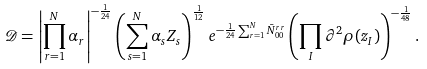Convert formula to latex. <formula><loc_0><loc_0><loc_500><loc_500>\mathcal { D } = \left | \prod _ { r = 1 } ^ { N } \alpha _ { r } \right | ^ { - \frac { 1 } { 2 4 } } \left ( \sum _ { s = 1 } ^ { N } \alpha _ { s } Z _ { s } \right ) ^ { \frac { 1 } { 1 2 } } e ^ { - \frac { 1 } { 2 4 } \sum _ { r = 1 } ^ { N } \bar { N } ^ { r r } _ { 0 0 } } \left ( \prod _ { I } \partial ^ { 2 } \rho ( z _ { I } ) \right ) ^ { - \frac { 1 } { 4 8 } } .</formula> 